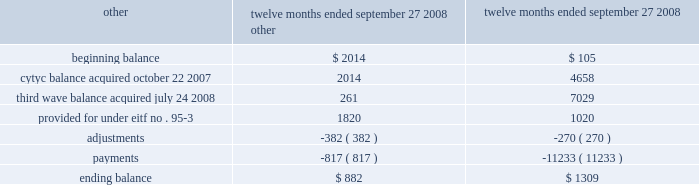Hologic , inc .
Notes to consolidated financial statements ( continued ) ( in thousands , except per share data ) restructuring accrual as a result of the cytyc merger , the company assumed previous cytyc management approved restructuring plans designed to reduce future operating expenses by consolidating its mountain view , california operations into its existing operations in costa rica and massachusetts as well as restructuring plans relating to cytyc 2019s historical acquisitions completed in march 2007 .
In connection with these plans , the company assumed a total liability of approximately $ 4658 .
During the twelve months ended september 27 , 2008 , the company did not incur any additional restructuring costs related to retention costs for these employees .
As a result of the third wave acquisition , the company assumed previous third wave management approved restructuring plans designed to reduce future operating expenses .
In connection with these plans , the company assumed a total liability related to termination benefits of approximately $ 7509 .
The company did not incur any additional restructuring costs related to retention costs for these employees from the date of acquisition through september 27 , 2008 .
We anticipate that these costs will be paid in full during fiscal 2009 .
Additionally , the company recorded a liability related to the cytyc merger in accordance with eitf 95-3 as detailed below , primarily related to the termination of certain employees as well as minimum inventory purchase commitments and other contractual obligations for which business activities have been discontinued .
During the twelve months ended september 27 , 2008 the company incurred approximately $ 6.4 million of expense related to the resignation of the chairman of the board of directors , which is not included in the table below ( see note 12 ) .
Changes in the restructuring accrual for the twelve months ended september 27 , 2008 were as follows : twelve months ended september 27 , 2008 termination benefits .
As of the dates of acquisition of aeg elektrofotografie gmbh ( 201caeg 201d ) , r2 technology , inc .
( 201cr2 201d ) and suros surgical , inc .
( 201csuros 201d ) ( see note 3 ) , management of the company implemented and finalized plans to involuntarily terminate certain employees of the acquired companies .
These plans resulted in a liability for costs associated with an employee severance arrangement of approximately $ 3135 in accordance with eitf issue no .
95-3 , recognition of liabilities in connection with a purchase business combination .
As of september 29 , 2007 , all amounts other than $ 105 had been paid .
The company had made full payment on this remaining liability as of september 27 , 2008 .
Advertising costs advertising costs are charged to operations as incurred .
The company does not have any direct-response advertising .
Advertising costs , which include trade shows and conventions , were approximately $ 15281 , $ 6683 and $ 5003 for fiscal 2008 , 2007 and 2006 , respectively , and were included in selling and marketing expense in the consolidated statements of operations. .
What is the growth rate in advertising costs from 2006 to 2007? 
Computations: ((6683 - 5003) / 5003)
Answer: 0.3358. Hologic , inc .
Notes to consolidated financial statements ( continued ) ( in thousands , except per share data ) restructuring accrual as a result of the cytyc merger , the company assumed previous cytyc management approved restructuring plans designed to reduce future operating expenses by consolidating its mountain view , california operations into its existing operations in costa rica and massachusetts as well as restructuring plans relating to cytyc 2019s historical acquisitions completed in march 2007 .
In connection with these plans , the company assumed a total liability of approximately $ 4658 .
During the twelve months ended september 27 , 2008 , the company did not incur any additional restructuring costs related to retention costs for these employees .
As a result of the third wave acquisition , the company assumed previous third wave management approved restructuring plans designed to reduce future operating expenses .
In connection with these plans , the company assumed a total liability related to termination benefits of approximately $ 7509 .
The company did not incur any additional restructuring costs related to retention costs for these employees from the date of acquisition through september 27 , 2008 .
We anticipate that these costs will be paid in full during fiscal 2009 .
Additionally , the company recorded a liability related to the cytyc merger in accordance with eitf 95-3 as detailed below , primarily related to the termination of certain employees as well as minimum inventory purchase commitments and other contractual obligations for which business activities have been discontinued .
During the twelve months ended september 27 , 2008 the company incurred approximately $ 6.4 million of expense related to the resignation of the chairman of the board of directors , which is not included in the table below ( see note 12 ) .
Changes in the restructuring accrual for the twelve months ended september 27 , 2008 were as follows : twelve months ended september 27 , 2008 termination benefits .
As of the dates of acquisition of aeg elektrofotografie gmbh ( 201caeg 201d ) , r2 technology , inc .
( 201cr2 201d ) and suros surgical , inc .
( 201csuros 201d ) ( see note 3 ) , management of the company implemented and finalized plans to involuntarily terminate certain employees of the acquired companies .
These plans resulted in a liability for costs associated with an employee severance arrangement of approximately $ 3135 in accordance with eitf issue no .
95-3 , recognition of liabilities in connection with a purchase business combination .
As of september 29 , 2007 , all amounts other than $ 105 had been paid .
The company had made full payment on this remaining liability as of september 27 , 2008 .
Advertising costs advertising costs are charged to operations as incurred .
The company does not have any direct-response advertising .
Advertising costs , which include trade shows and conventions , were approximately $ 15281 , $ 6683 and $ 5003 for fiscal 2008 , 2007 and 2006 , respectively , and were included in selling and marketing expense in the consolidated statements of operations. .
What is the growth rate in advertising costs from 2007 to 2008? 
Computations: ((15281 - 6683) / 6683)
Answer: 1.28655. 